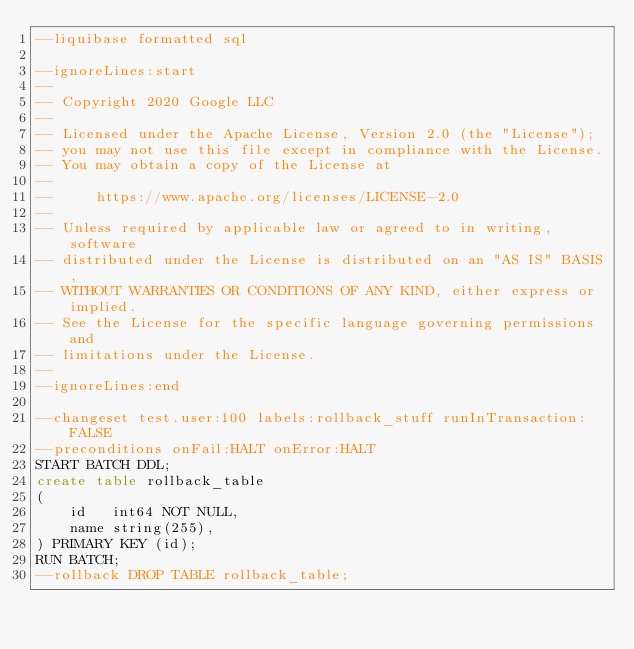Convert code to text. <code><loc_0><loc_0><loc_500><loc_500><_SQL_>--liquibase formatted sql

--ignoreLines:start
--
-- Copyright 2020 Google LLC
--
-- Licensed under the Apache License, Version 2.0 (the "License");
-- you may not use this file except in compliance with the License.
-- You may obtain a copy of the License at
--
--     https://www.apache.org/licenses/LICENSE-2.0
--
-- Unless required by applicable law or agreed to in writing, software
-- distributed under the License is distributed on an "AS IS" BASIS,
-- WITHOUT WARRANTIES OR CONDITIONS OF ANY KIND, either express or implied.
-- See the License for the specific language governing permissions and
-- limitations under the License.
--
--ignoreLines:end

--changeset test.user:100 labels:rollback_stuff runInTransaction:FALSE
--preconditions onFail:HALT onError:HALT
START BATCH DDL;
create table rollback_table
(
    id   int64 NOT NULL,
    name string(255),
) PRIMARY KEY (id);
RUN BATCH;
--rollback DROP TABLE rollback_table;

</code> 